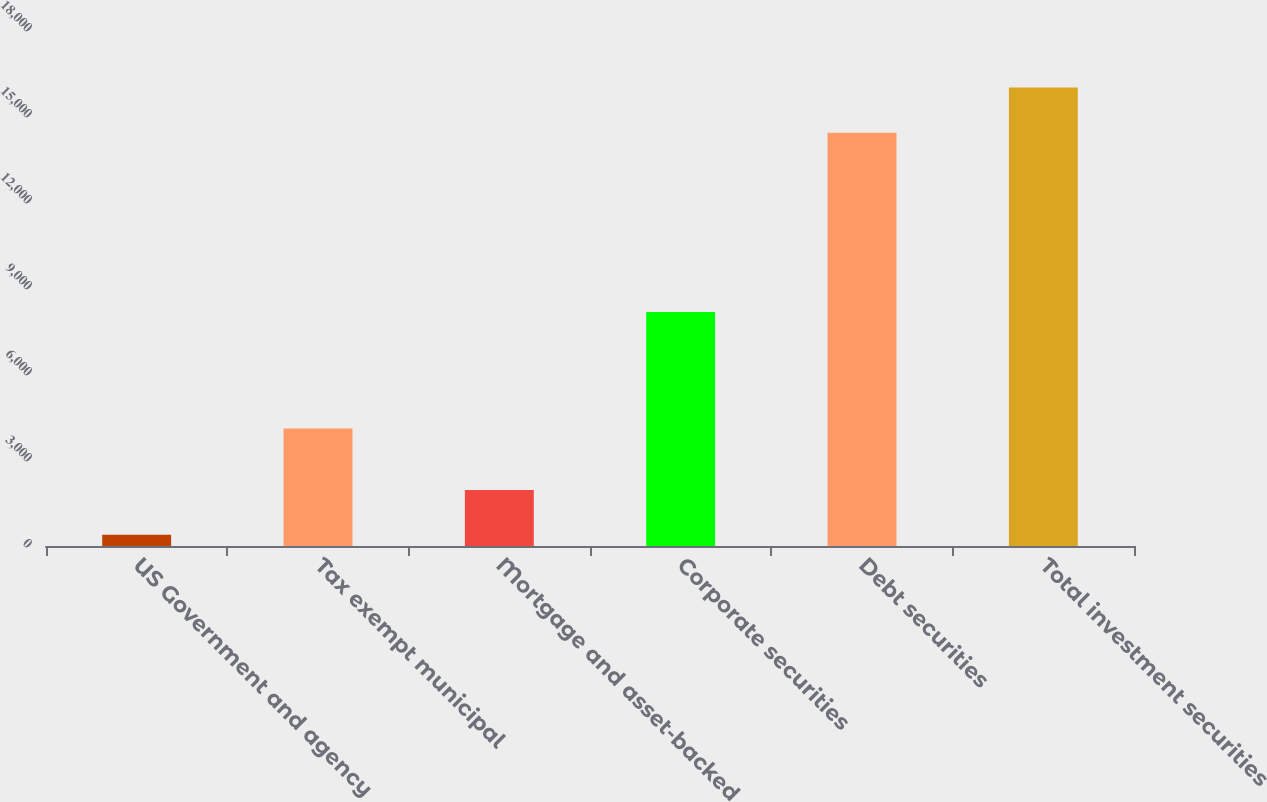Convert chart. <chart><loc_0><loc_0><loc_500><loc_500><bar_chart><fcel>US Government and agency<fcel>Tax exempt municipal<fcel>Mortgage and asset-backed<fcel>Corporate securities<fcel>Debt securities<fcel>Total investment securities<nl><fcel>391<fcel>4098<fcel>1951.2<fcel>8161<fcel>14416<fcel>15993<nl></chart> 